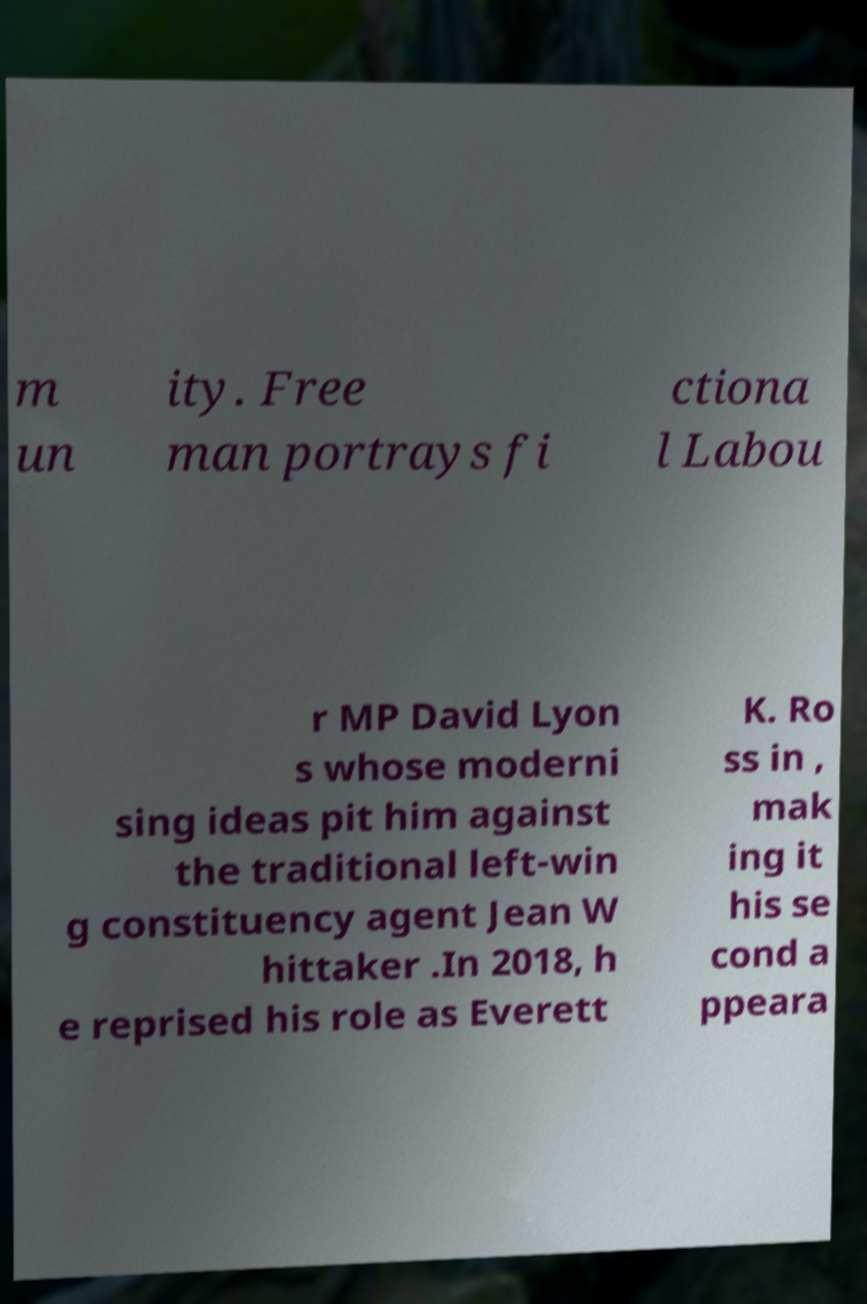There's text embedded in this image that I need extracted. Can you transcribe it verbatim? m un ity. Free man portrays fi ctiona l Labou r MP David Lyon s whose moderni sing ideas pit him against the traditional left-win g constituency agent Jean W hittaker .In 2018, h e reprised his role as Everett K. Ro ss in , mak ing it his se cond a ppeara 